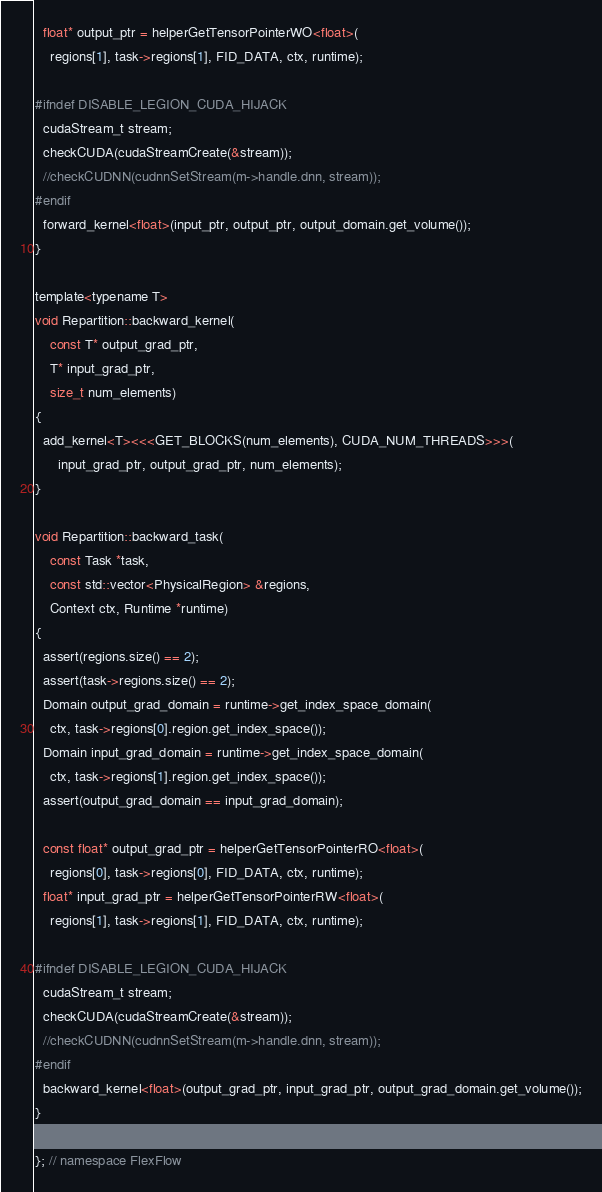<code> <loc_0><loc_0><loc_500><loc_500><_Cuda_>  float* output_ptr = helperGetTensorPointerWO<float>(
    regions[1], task->regions[1], FID_DATA, ctx, runtime);

#ifndef DISABLE_LEGION_CUDA_HIJACK
  cudaStream_t stream;
  checkCUDA(cudaStreamCreate(&stream));
  //checkCUDNN(cudnnSetStream(m->handle.dnn, stream));
#endif
  forward_kernel<float>(input_ptr, output_ptr, output_domain.get_volume());
}

template<typename T>
void Repartition::backward_kernel(
    const T* output_grad_ptr,
    T* input_grad_ptr,
    size_t num_elements)
{
  add_kernel<T><<<GET_BLOCKS(num_elements), CUDA_NUM_THREADS>>>(
      input_grad_ptr, output_grad_ptr, num_elements);
}

void Repartition::backward_task(
    const Task *task,
    const std::vector<PhysicalRegion> &regions,
    Context ctx, Runtime *runtime)
{
  assert(regions.size() == 2);
  assert(task->regions.size() == 2);
  Domain output_grad_domain = runtime->get_index_space_domain(
    ctx, task->regions[0].region.get_index_space());
  Domain input_grad_domain = runtime->get_index_space_domain(
    ctx, task->regions[1].region.get_index_space());
  assert(output_grad_domain == input_grad_domain);

  const float* output_grad_ptr = helperGetTensorPointerRO<float>(
    regions[0], task->regions[0], FID_DATA, ctx, runtime);
  float* input_grad_ptr = helperGetTensorPointerRW<float>(
    regions[1], task->regions[1], FID_DATA, ctx, runtime);

#ifndef DISABLE_LEGION_CUDA_HIJACK
  cudaStream_t stream;
  checkCUDA(cudaStreamCreate(&stream));
  //checkCUDNN(cudnnSetStream(m->handle.dnn, stream));
#endif
  backward_kernel<float>(output_grad_ptr, input_grad_ptr, output_grad_domain.get_volume());
}

}; // namespace FlexFlow
</code> 